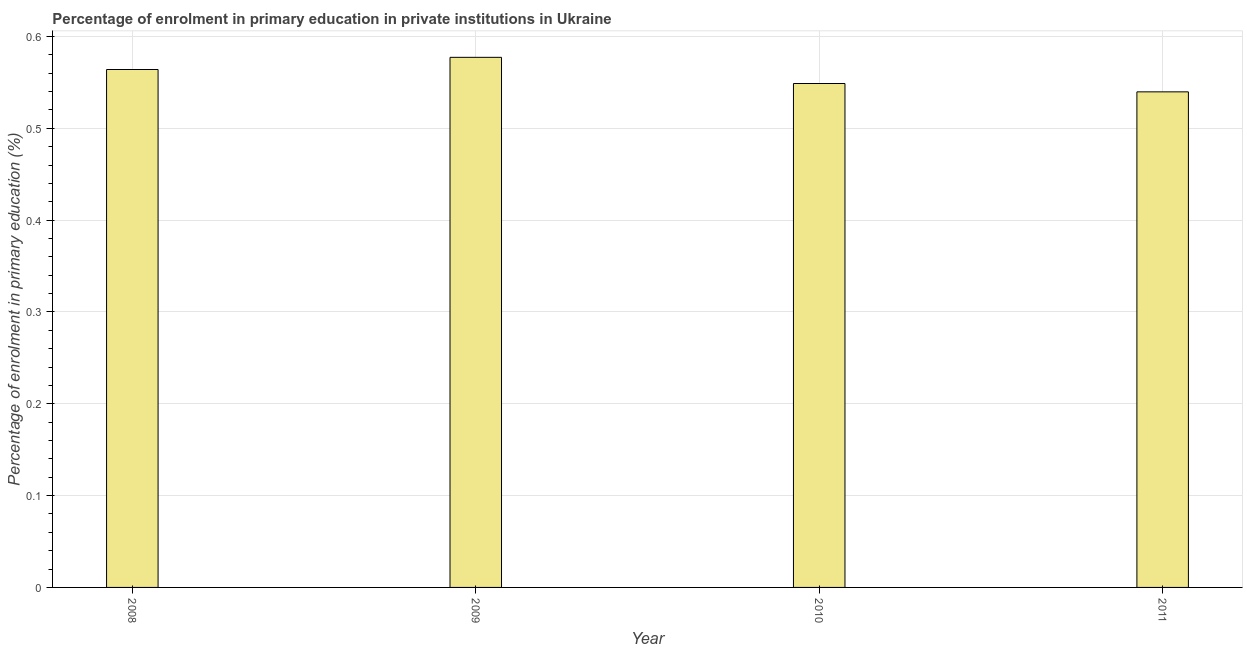What is the title of the graph?
Your response must be concise. Percentage of enrolment in primary education in private institutions in Ukraine. What is the label or title of the Y-axis?
Ensure brevity in your answer.  Percentage of enrolment in primary education (%). What is the enrolment percentage in primary education in 2011?
Give a very brief answer. 0.54. Across all years, what is the maximum enrolment percentage in primary education?
Keep it short and to the point. 0.58. Across all years, what is the minimum enrolment percentage in primary education?
Keep it short and to the point. 0.54. In which year was the enrolment percentage in primary education maximum?
Ensure brevity in your answer.  2009. In which year was the enrolment percentage in primary education minimum?
Your response must be concise. 2011. What is the sum of the enrolment percentage in primary education?
Your response must be concise. 2.23. What is the difference between the enrolment percentage in primary education in 2010 and 2011?
Your answer should be very brief. 0.01. What is the average enrolment percentage in primary education per year?
Make the answer very short. 0.56. What is the median enrolment percentage in primary education?
Provide a succinct answer. 0.56. In how many years, is the enrolment percentage in primary education greater than 0.08 %?
Provide a succinct answer. 4. Do a majority of the years between 2008 and 2010 (inclusive) have enrolment percentage in primary education greater than 0.52 %?
Your response must be concise. Yes. What is the difference between the highest and the second highest enrolment percentage in primary education?
Keep it short and to the point. 0.01. What is the difference between the highest and the lowest enrolment percentage in primary education?
Your response must be concise. 0.04. How many bars are there?
Keep it short and to the point. 4. Are all the bars in the graph horizontal?
Give a very brief answer. No. What is the difference between two consecutive major ticks on the Y-axis?
Offer a terse response. 0.1. Are the values on the major ticks of Y-axis written in scientific E-notation?
Offer a very short reply. No. What is the Percentage of enrolment in primary education (%) in 2008?
Offer a terse response. 0.56. What is the Percentage of enrolment in primary education (%) in 2009?
Your response must be concise. 0.58. What is the Percentage of enrolment in primary education (%) of 2010?
Your answer should be very brief. 0.55. What is the Percentage of enrolment in primary education (%) of 2011?
Give a very brief answer. 0.54. What is the difference between the Percentage of enrolment in primary education (%) in 2008 and 2009?
Offer a very short reply. -0.01. What is the difference between the Percentage of enrolment in primary education (%) in 2008 and 2010?
Ensure brevity in your answer.  0.02. What is the difference between the Percentage of enrolment in primary education (%) in 2008 and 2011?
Provide a short and direct response. 0.02. What is the difference between the Percentage of enrolment in primary education (%) in 2009 and 2010?
Provide a short and direct response. 0.03. What is the difference between the Percentage of enrolment in primary education (%) in 2009 and 2011?
Provide a succinct answer. 0.04. What is the difference between the Percentage of enrolment in primary education (%) in 2010 and 2011?
Your answer should be very brief. 0.01. What is the ratio of the Percentage of enrolment in primary education (%) in 2008 to that in 2009?
Give a very brief answer. 0.98. What is the ratio of the Percentage of enrolment in primary education (%) in 2008 to that in 2010?
Your answer should be compact. 1.03. What is the ratio of the Percentage of enrolment in primary education (%) in 2008 to that in 2011?
Offer a terse response. 1.04. What is the ratio of the Percentage of enrolment in primary education (%) in 2009 to that in 2010?
Keep it short and to the point. 1.05. What is the ratio of the Percentage of enrolment in primary education (%) in 2009 to that in 2011?
Make the answer very short. 1.07. What is the ratio of the Percentage of enrolment in primary education (%) in 2010 to that in 2011?
Give a very brief answer. 1.02. 